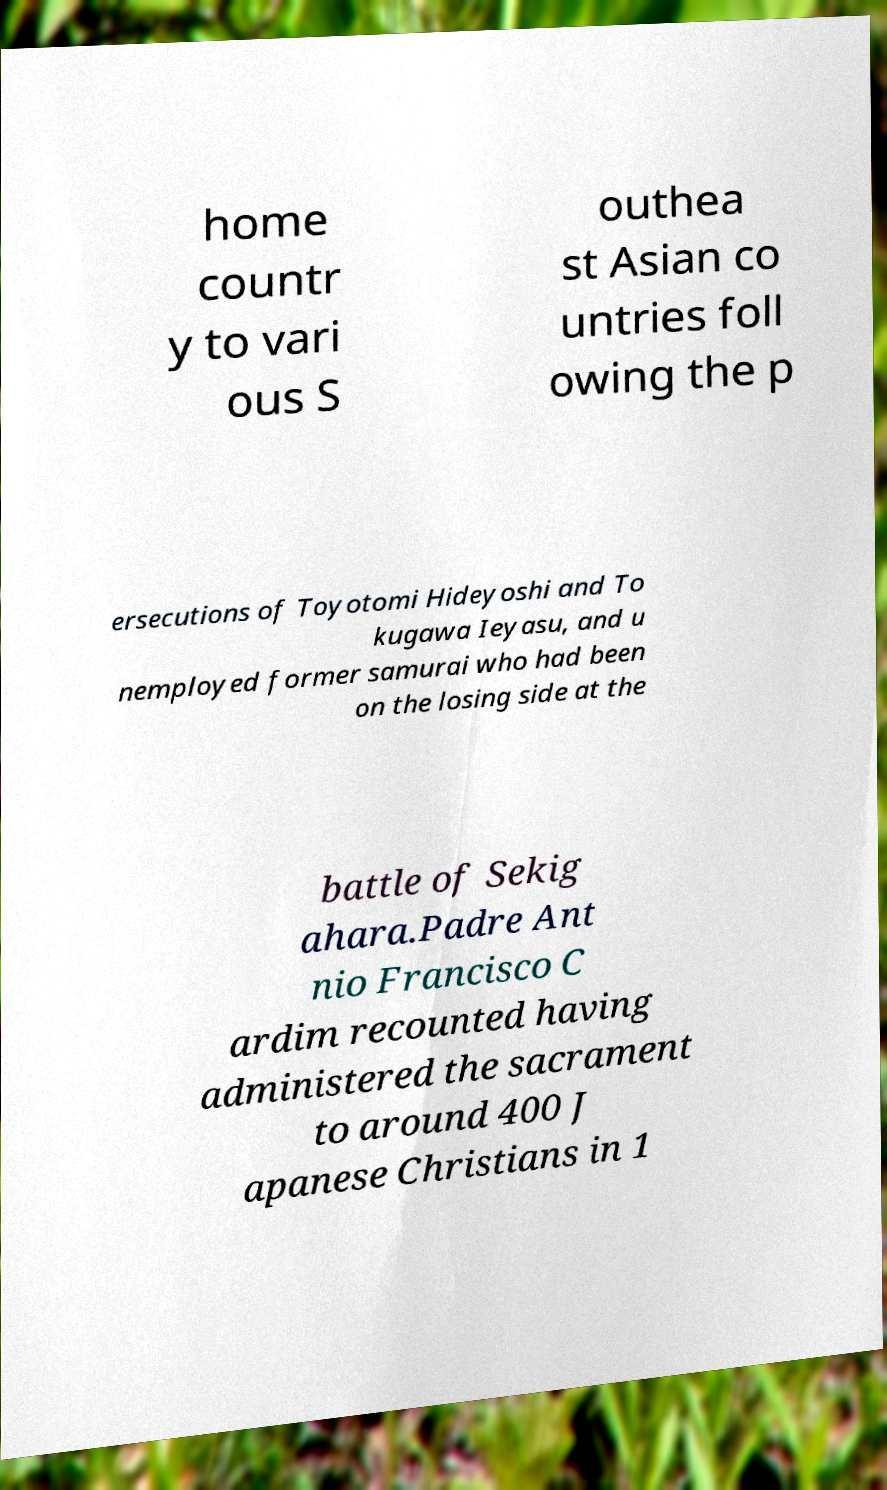I need the written content from this picture converted into text. Can you do that? home countr y to vari ous S outhea st Asian co untries foll owing the p ersecutions of Toyotomi Hideyoshi and To kugawa Ieyasu, and u nemployed former samurai who had been on the losing side at the battle of Sekig ahara.Padre Ant nio Francisco C ardim recounted having administered the sacrament to around 400 J apanese Christians in 1 